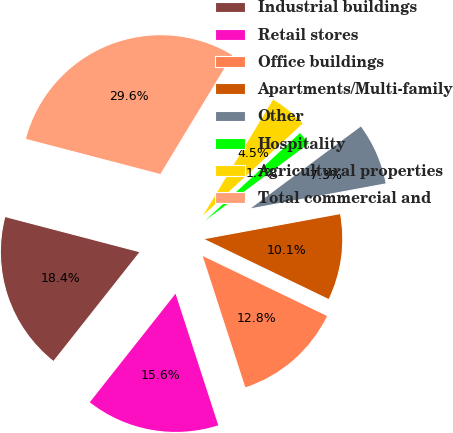Convert chart to OTSL. <chart><loc_0><loc_0><loc_500><loc_500><pie_chart><fcel>Industrial buildings<fcel>Retail stores<fcel>Office buildings<fcel>Apartments/Multi-family<fcel>Other<fcel>Hospitality<fcel>Agricultural properties<fcel>Total commercial and<nl><fcel>18.43%<fcel>15.64%<fcel>12.85%<fcel>10.06%<fcel>7.27%<fcel>1.69%<fcel>4.48%<fcel>29.59%<nl></chart> 